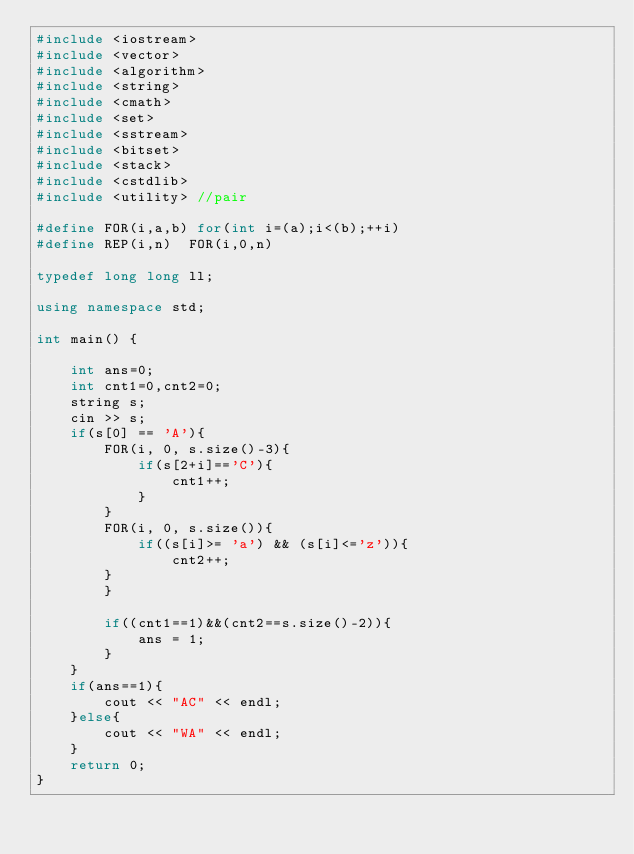<code> <loc_0><loc_0><loc_500><loc_500><_C++_>#include <iostream>
#include <vector>
#include <algorithm>
#include <string>
#include <cmath>
#include <set>
#include <sstream>
#include <bitset>
#include <stack>
#include <cstdlib>
#include <utility> //pair

#define FOR(i,a,b) for(int i=(a);i<(b);++i)
#define REP(i,n)  FOR(i,0,n)

typedef long long ll;

using namespace std;

int main() {
    
    int ans=0;
    int cnt1=0,cnt2=0;
    string s;
    cin >> s;
    if(s[0] == 'A'){
        FOR(i, 0, s.size()-3){
            if(s[2+i]=='C'){
                cnt1++;
            }
        }
        FOR(i, 0, s.size()){
            if((s[i]>= 'a') && (s[i]<='z')){
                cnt2++;
        }
        }
        
        if((cnt1==1)&&(cnt2==s.size()-2)){
            ans = 1;
        }
    }
    if(ans==1){
        cout << "AC" << endl;
    }else{
        cout << "WA" << endl;
    }
    return 0;
}

</code> 